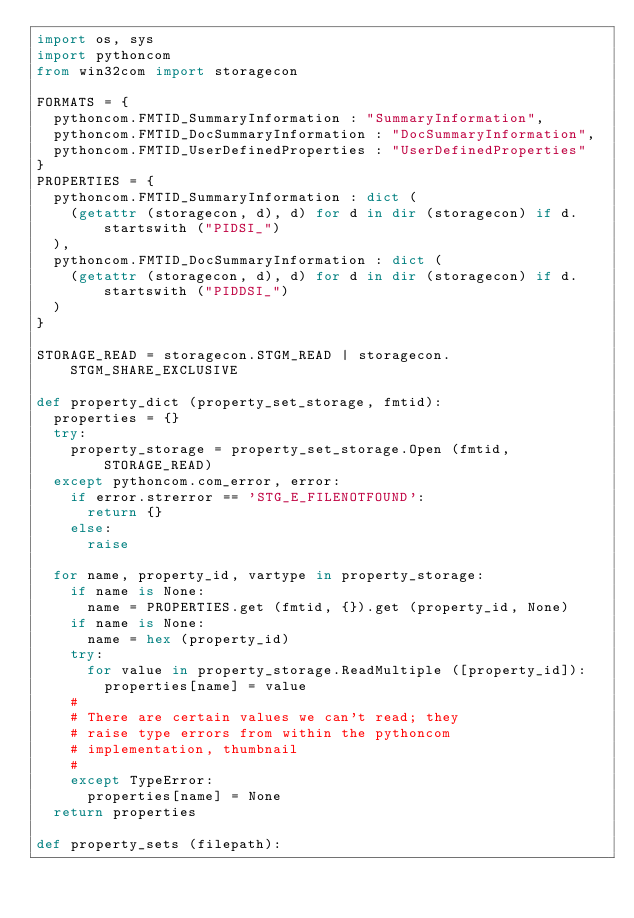<code> <loc_0><loc_0><loc_500><loc_500><_Python_>import os, sys
import pythoncom
from win32com import storagecon

FORMATS = {
  pythoncom.FMTID_SummaryInformation : "SummaryInformation",
  pythoncom.FMTID_DocSummaryInformation : "DocSummaryInformation",
  pythoncom.FMTID_UserDefinedProperties : "UserDefinedProperties"
}
PROPERTIES = {
  pythoncom.FMTID_SummaryInformation : dict (
    (getattr (storagecon, d), d) for d in dir (storagecon) if d.startswith ("PIDSI_")
  ),
  pythoncom.FMTID_DocSummaryInformation : dict (
    (getattr (storagecon, d), d) for d in dir (storagecon) if d.startswith ("PIDDSI_")
  )
}

STORAGE_READ = storagecon.STGM_READ | storagecon.STGM_SHARE_EXCLUSIVE

def property_dict (property_set_storage, fmtid):
  properties = {}
  try:
    property_storage = property_set_storage.Open (fmtid, STORAGE_READ)
  except pythoncom.com_error, error:
    if error.strerror == 'STG_E_FILENOTFOUND':
      return {}
    else:
      raise
      
  for name, property_id, vartype in property_storage:
    if name is None:
      name = PROPERTIES.get (fmtid, {}).get (property_id, None)
    if name is None:
      name = hex (property_id)
    try:
      for value in property_storage.ReadMultiple ([property_id]):
        properties[name] = value
    #
    # There are certain values we can't read; they
    # raise type errors from within the pythoncom
    # implementation, thumbnail
    #
    except TypeError:
      properties[name] = None
  return properties
  
def property_sets (filepath):</code> 